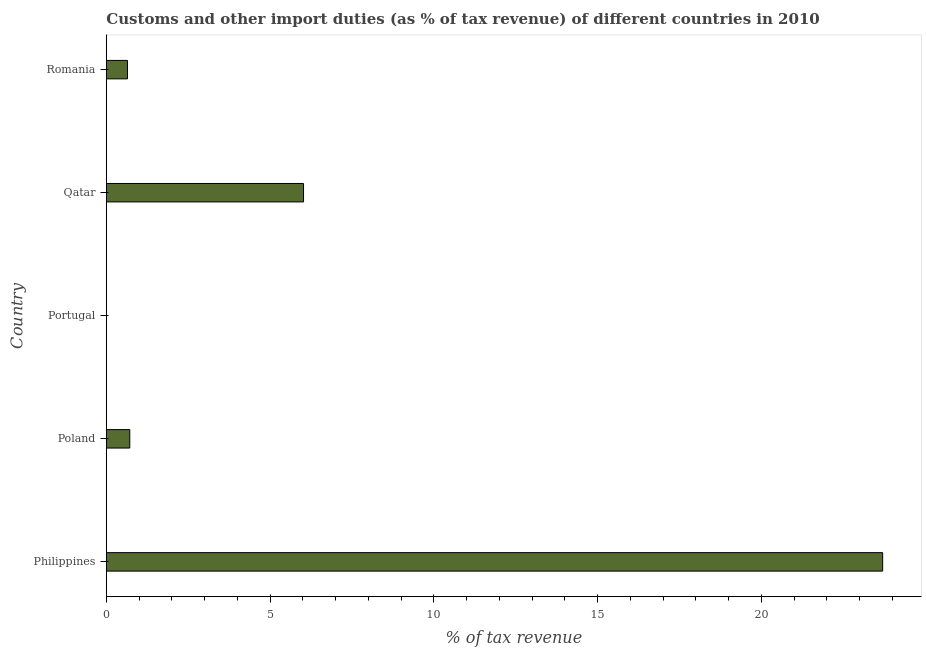Does the graph contain any zero values?
Provide a short and direct response. No. What is the title of the graph?
Offer a terse response. Customs and other import duties (as % of tax revenue) of different countries in 2010. What is the label or title of the X-axis?
Offer a very short reply. % of tax revenue. What is the label or title of the Y-axis?
Provide a short and direct response. Country. What is the customs and other import duties in Romania?
Provide a succinct answer. 0.65. Across all countries, what is the maximum customs and other import duties?
Offer a terse response. 23.7. Across all countries, what is the minimum customs and other import duties?
Give a very brief answer. 0. In which country was the customs and other import duties maximum?
Your answer should be very brief. Philippines. In which country was the customs and other import duties minimum?
Your answer should be very brief. Portugal. What is the sum of the customs and other import duties?
Provide a succinct answer. 31.09. What is the difference between the customs and other import duties in Philippines and Portugal?
Provide a short and direct response. 23.7. What is the average customs and other import duties per country?
Offer a very short reply. 6.22. What is the median customs and other import duties?
Keep it short and to the point. 0.72. In how many countries, is the customs and other import duties greater than 9 %?
Keep it short and to the point. 1. What is the difference between the highest and the second highest customs and other import duties?
Your answer should be very brief. 17.68. Is the sum of the customs and other import duties in Poland and Portugal greater than the maximum customs and other import duties across all countries?
Your response must be concise. No. What is the difference between the highest and the lowest customs and other import duties?
Ensure brevity in your answer.  23.7. How many bars are there?
Offer a very short reply. 5. How many countries are there in the graph?
Offer a very short reply. 5. Are the values on the major ticks of X-axis written in scientific E-notation?
Your answer should be very brief. No. What is the % of tax revenue in Philippines?
Provide a succinct answer. 23.7. What is the % of tax revenue in Poland?
Offer a terse response. 0.72. What is the % of tax revenue in Portugal?
Ensure brevity in your answer.  0. What is the % of tax revenue of Qatar?
Your response must be concise. 6.02. What is the % of tax revenue in Romania?
Provide a short and direct response. 0.65. What is the difference between the % of tax revenue in Philippines and Poland?
Provide a succinct answer. 22.99. What is the difference between the % of tax revenue in Philippines and Portugal?
Offer a very short reply. 23.7. What is the difference between the % of tax revenue in Philippines and Qatar?
Make the answer very short. 17.68. What is the difference between the % of tax revenue in Philippines and Romania?
Offer a very short reply. 23.06. What is the difference between the % of tax revenue in Poland and Portugal?
Keep it short and to the point. 0.71. What is the difference between the % of tax revenue in Poland and Qatar?
Provide a succinct answer. -5.31. What is the difference between the % of tax revenue in Poland and Romania?
Give a very brief answer. 0.07. What is the difference between the % of tax revenue in Portugal and Qatar?
Keep it short and to the point. -6.02. What is the difference between the % of tax revenue in Portugal and Romania?
Your answer should be very brief. -0.64. What is the difference between the % of tax revenue in Qatar and Romania?
Give a very brief answer. 5.38. What is the ratio of the % of tax revenue in Philippines to that in Poland?
Keep it short and to the point. 33.1. What is the ratio of the % of tax revenue in Philippines to that in Portugal?
Your response must be concise. 7764.31. What is the ratio of the % of tax revenue in Philippines to that in Qatar?
Ensure brevity in your answer.  3.94. What is the ratio of the % of tax revenue in Philippines to that in Romania?
Your answer should be compact. 36.73. What is the ratio of the % of tax revenue in Poland to that in Portugal?
Your answer should be compact. 234.53. What is the ratio of the % of tax revenue in Poland to that in Qatar?
Provide a short and direct response. 0.12. What is the ratio of the % of tax revenue in Poland to that in Romania?
Keep it short and to the point. 1.11. What is the ratio of the % of tax revenue in Portugal to that in Romania?
Make the answer very short. 0.01. What is the ratio of the % of tax revenue in Qatar to that in Romania?
Your answer should be compact. 9.33. 